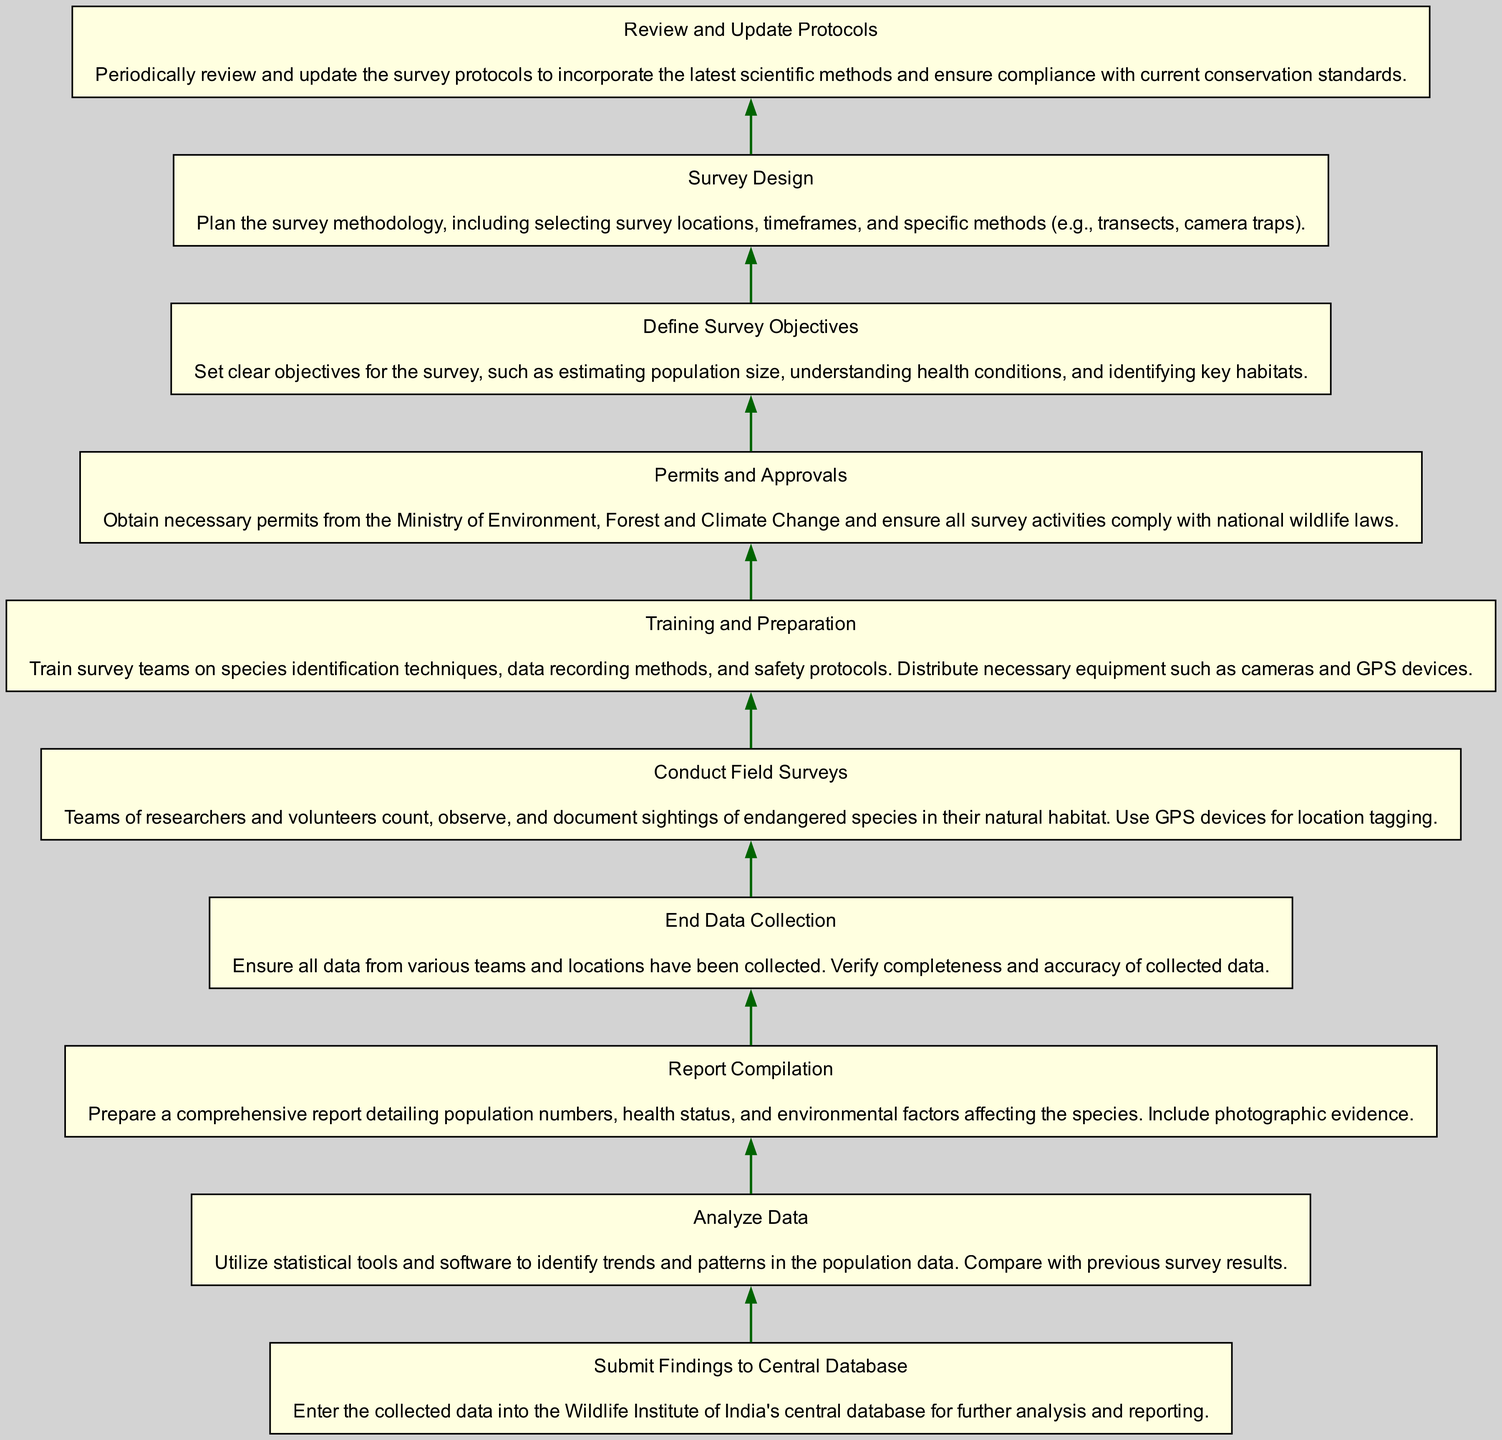What is the first step in conducting endangered species population surveys? The first step in the flow chart is "Define Survey Objectives," which outlines the goals for the survey.
Answer: Define Survey Objectives What follows "Training and Preparation" in the flow? After "Training and Preparation," the next step is "Permits and Approvals," which involves obtaining necessary permits for the survey activities.
Answer: Permits and Approvals How many nodes are in the diagram? There are ten nodes in the diagram, each representing a step in the procedure for conducting surveys.
Answer: Ten What action is taken after "End Data Collection"? After "End Data Collection," the next action is "Analyze Data," which involves utilizing statistical tools to identify trends.
Answer: Analyze Data What does "Conduct Field Surveys" entail? "Conduct Field Surveys" entails teams counting, observing, and documenting sightings of endangered species in their natural habitat using GPS devices.
Answer: Counting and observing What is the last step listed in the flow chart? The last step listed in the flow chart is "Submit Findings to Central Database," which involves entering collected data for further analysis.
Answer: Submit Findings to Central Database What is necessary before conducting field surveys according to the flow? According to the flow, "Permits and Approvals" must be obtained before conducting field surveys to ensure compliance with laws.
Answer: Permits and Approvals What is the purpose of "Analyze Data" in the procedure? The purpose of "Analyze Data" is to utilize statistical tools to identify population trends and compare them with previous survey results.
Answer: Identify trends How does "Review and Update Protocols" impact the survey process? "Review and Update Protocols" ensures that the survey methodologies incorporate the latest scientific methods and comply with current conservation standards, impacting future surveys.
Answer: Ensures compliance What is indicated by the direction of flow in this diagram? The flow direction indicates a sequential process where each step must be completed before moving to the next, ensuring a systematic approach to the surveys.
Answer: Sequential process 